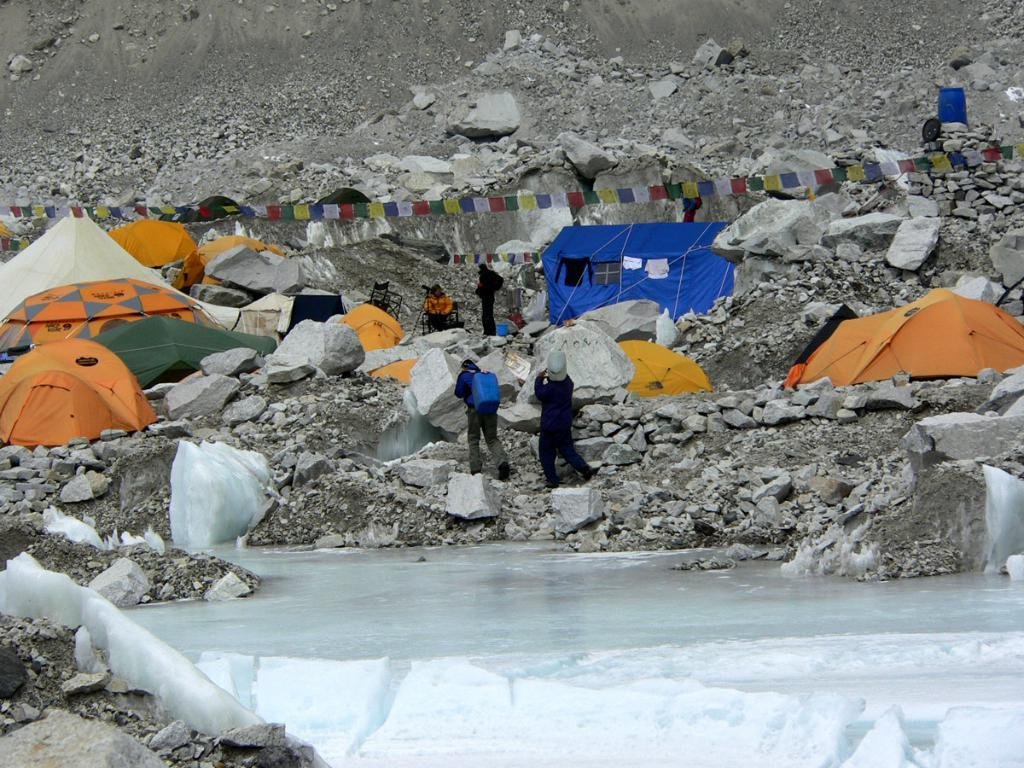What is located at the bottom of the image? There is a small pond at the bottom of the image. What is the weather like in the image? There is snow in the image, indicating a cold environment. What can be seen in the background of the image? There are mountains and tents in the background of the image. What are some people doing in the image? Some people are walking and standing in the image. Can you see a robin wearing a hat in the image? There is no robin or hat present in the image. What is the hope of the people in the image? The image does not provide information about the hopes or intentions of the people in the image. 